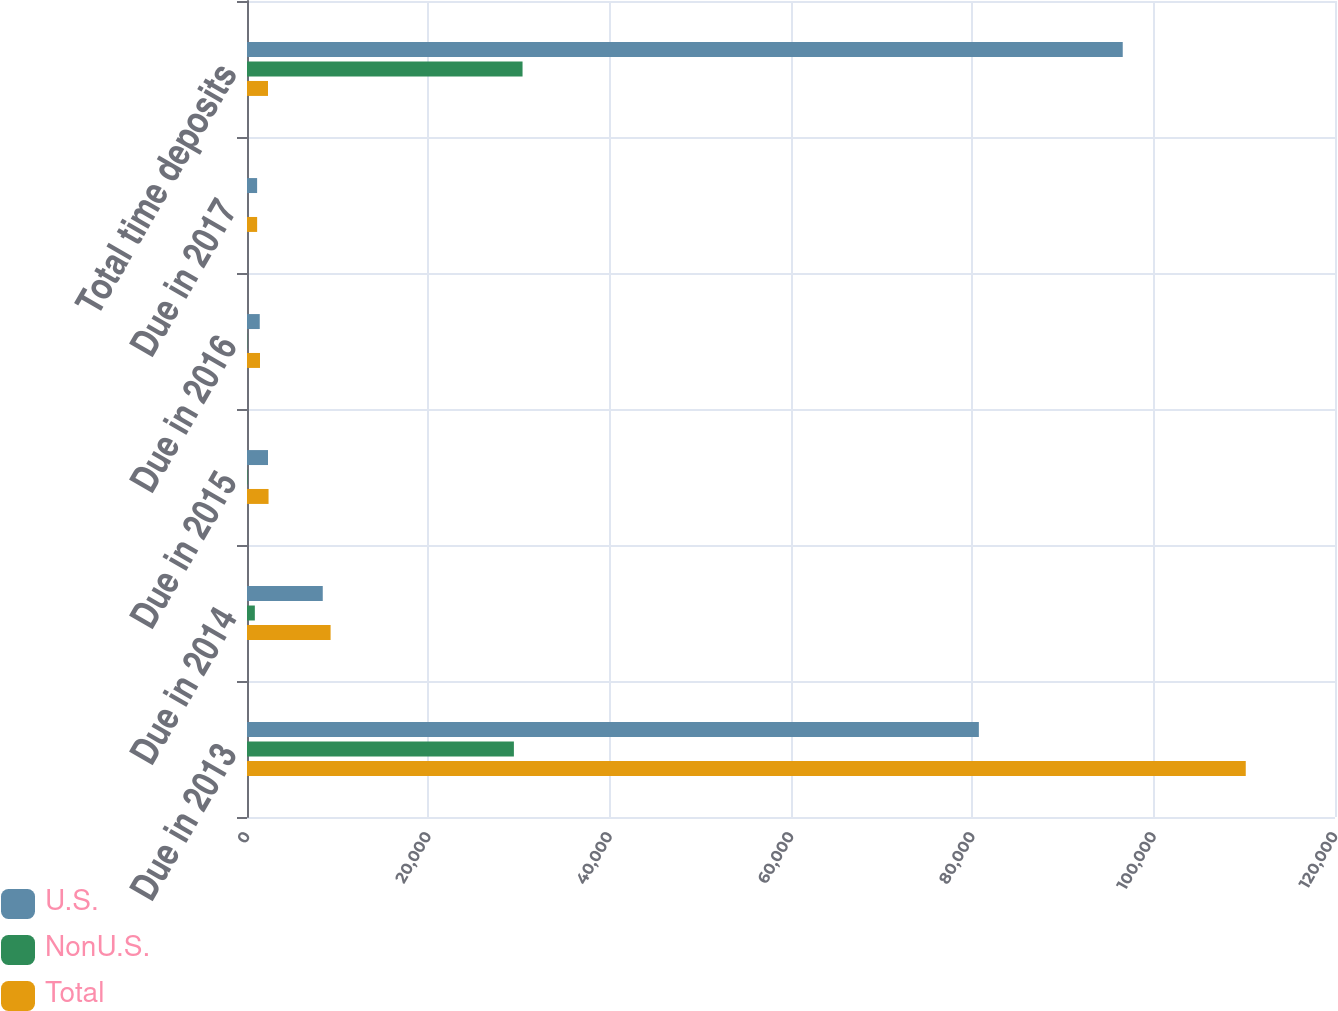Convert chart. <chart><loc_0><loc_0><loc_500><loc_500><stacked_bar_chart><ecel><fcel>Due in 2013<fcel>Due in 2014<fcel>Due in 2015<fcel>Due in 2016<fcel>Due in 2017<fcel>Total time deposits<nl><fcel>U.S.<fcel>80720<fcel>8356<fcel>2319<fcel>1407<fcel>1116<fcel>96589<nl><fcel>NonU.S.<fcel>29437<fcel>865<fcel>58<fcel>28<fcel>3<fcel>30391<nl><fcel>Total<fcel>110157<fcel>9221<fcel>2377<fcel>1435<fcel>1119<fcel>2319<nl></chart> 